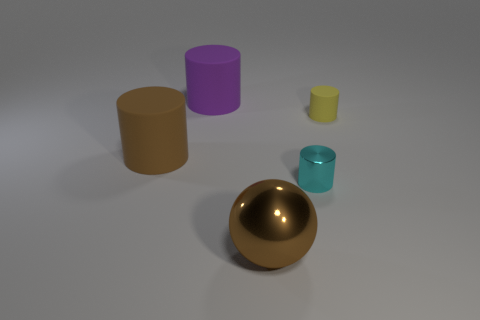Are there any other things that have the same shape as the big shiny object?
Your answer should be very brief. No. There is a small thing in front of the small yellow matte object; what is its color?
Your answer should be very brief. Cyan. How many gray metal cylinders are there?
Offer a terse response. 0. What is the shape of the brown thing that is the same material as the cyan object?
Make the answer very short. Sphere. There is a rubber object that is behind the yellow matte object; does it have the same color as the rubber thing on the right side of the big brown metal thing?
Keep it short and to the point. No. Are there the same number of small objects behind the large brown cylinder and big blue rubber balls?
Give a very brief answer. No. There is a yellow cylinder; what number of matte things are to the left of it?
Ensure brevity in your answer.  2. What size is the yellow thing?
Offer a terse response. Small. There is a tiny thing that is the same material as the brown cylinder; what color is it?
Offer a very short reply. Yellow. What number of brown rubber cylinders are the same size as the brown sphere?
Make the answer very short. 1. 